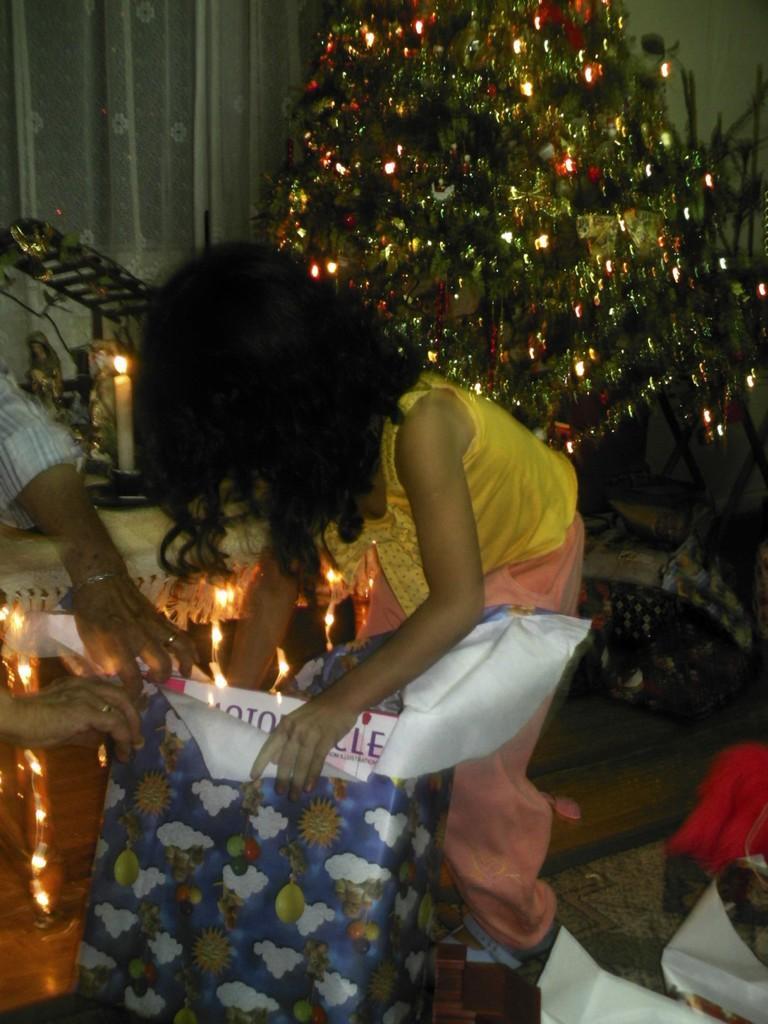In one or two sentences, can you explain what this image depicts? In the foreground of this image, there is a girl holding and opening a gift. On the left, there are hands of a person. In the background, there is a x mas tree, a candle and few sculptures on the table, we can also see the floor, carpet, wall and the curtain. 